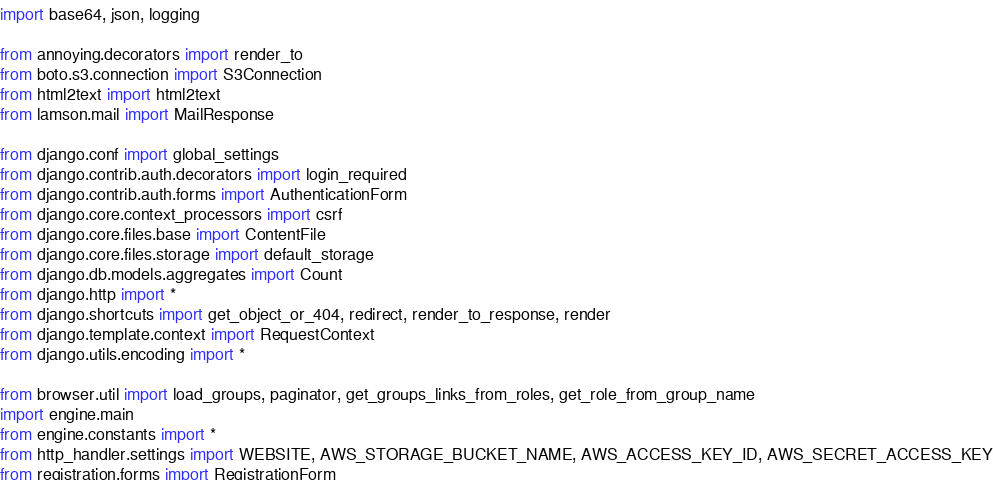<code> <loc_0><loc_0><loc_500><loc_500><_Python_>import base64, json, logging

from annoying.decorators import render_to
from boto.s3.connection import S3Connection
from html2text import html2text
from lamson.mail import MailResponse

from django.conf import global_settings
from django.contrib.auth.decorators import login_required
from django.contrib.auth.forms import AuthenticationForm
from django.core.context_processors import csrf
from django.core.files.base import ContentFile
from django.core.files.storage import default_storage
from django.db.models.aggregates import Count
from django.http import *
from django.shortcuts import get_object_or_404, redirect, render_to_response, render
from django.template.context import RequestContext
from django.utils.encoding import *

from browser.util import load_groups, paginator, get_groups_links_from_roles, get_role_from_group_name
import engine.main
from engine.constants import *
from http_handler.settings import WEBSITE, AWS_STORAGE_BUCKET_NAME, AWS_ACCESS_KEY_ID, AWS_SECRET_ACCESS_KEY
from registration.forms import RegistrationForm</code> 